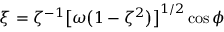Convert formula to latex. <formula><loc_0><loc_0><loc_500><loc_500>\xi = \zeta ^ { - 1 } \left [ \omega \left ( 1 - \zeta ^ { 2 } \right ) \right ] ^ { 1 / 2 } \cos \phi</formula> 